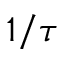Convert formula to latex. <formula><loc_0><loc_0><loc_500><loc_500>1 / \tau</formula> 